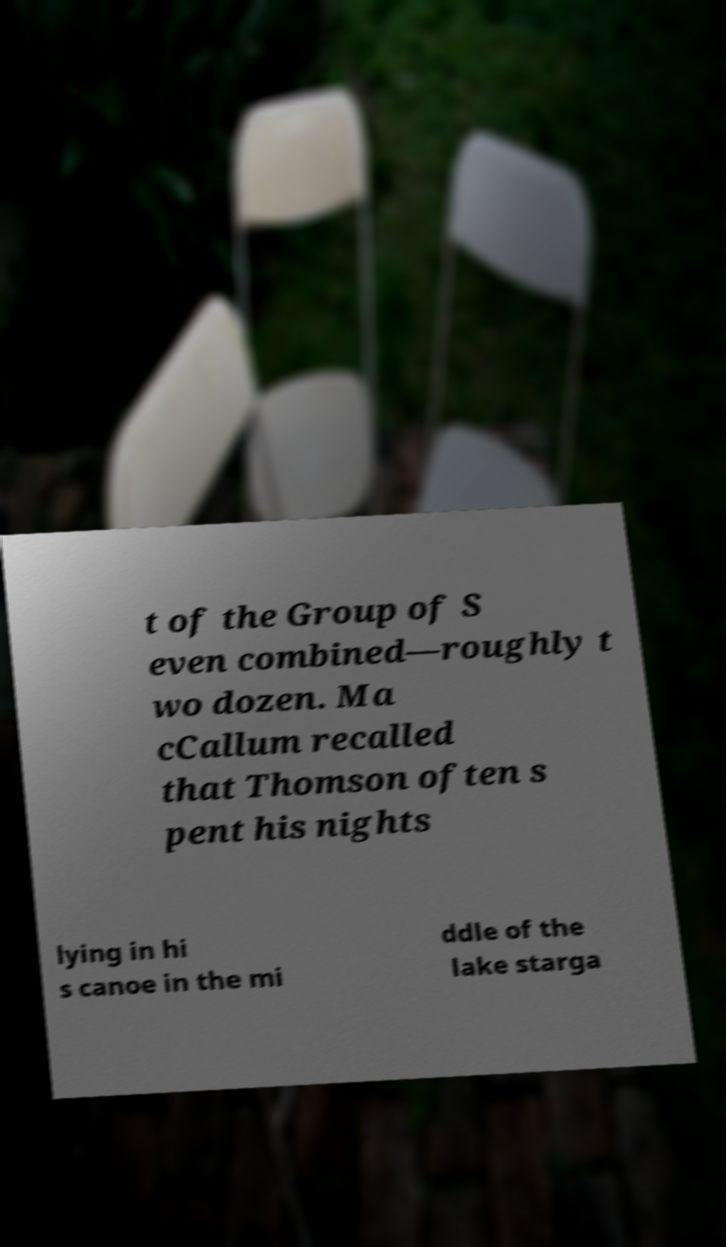Could you extract and type out the text from this image? t of the Group of S even combined—roughly t wo dozen. Ma cCallum recalled that Thomson often s pent his nights lying in hi s canoe in the mi ddle of the lake starga 